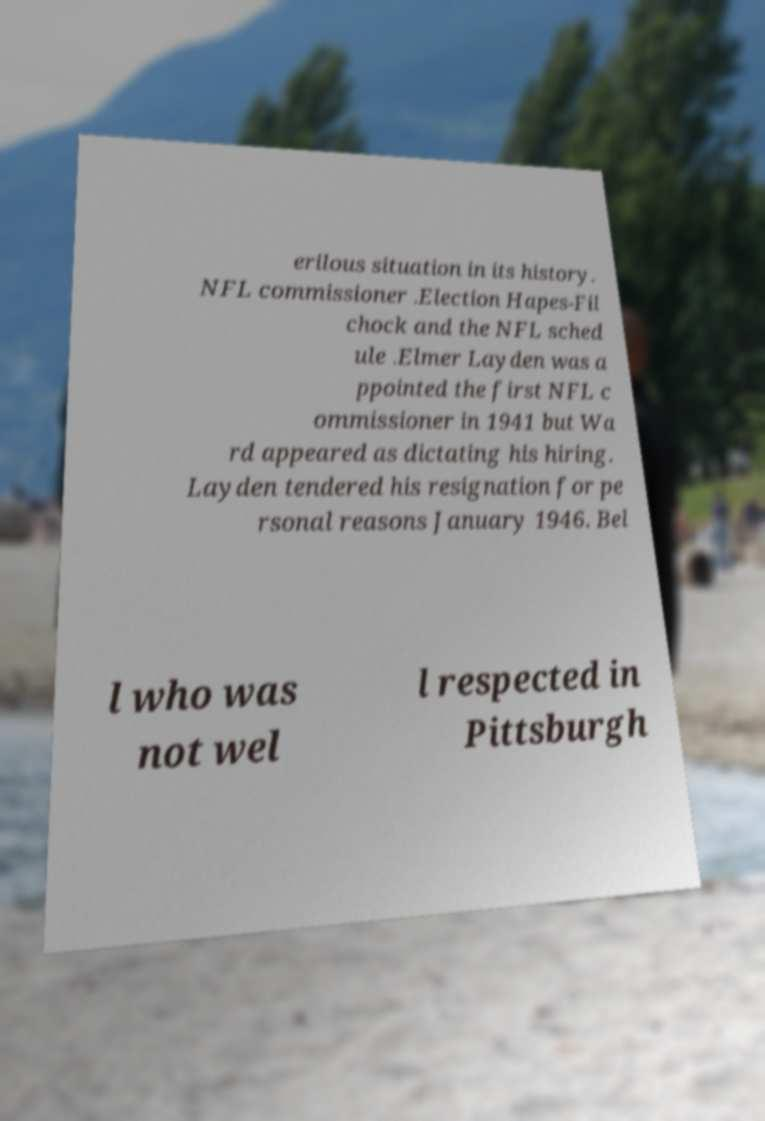I need the written content from this picture converted into text. Can you do that? erilous situation in its history. NFL commissioner .Election Hapes-Fil chock and the NFL sched ule .Elmer Layden was a ppointed the first NFL c ommissioner in 1941 but Wa rd appeared as dictating his hiring. Layden tendered his resignation for pe rsonal reasons January 1946. Bel l who was not wel l respected in Pittsburgh 